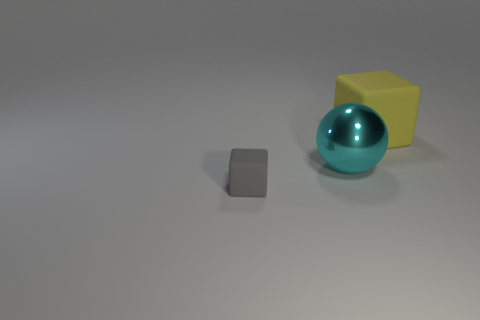Add 3 cyan rubber objects. How many objects exist? 6 Subtract all blocks. How many objects are left? 1 Subtract 0 purple balls. How many objects are left? 3 Subtract all big green metallic spheres. Subtract all large cubes. How many objects are left? 2 Add 2 matte blocks. How many matte blocks are left? 4 Add 1 big brown things. How many big brown things exist? 1 